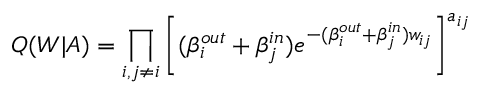Convert formula to latex. <formula><loc_0><loc_0><loc_500><loc_500>Q ( W | A ) = \prod _ { i , j \neq i } \left [ ( \beta _ { i } ^ { o u t } + \beta _ { j } ^ { i n } ) e ^ { - ( \beta _ { i } ^ { o u t } + \beta _ { j } ^ { i n } ) w _ { i j } } \right ] ^ { a _ { i j } }</formula> 